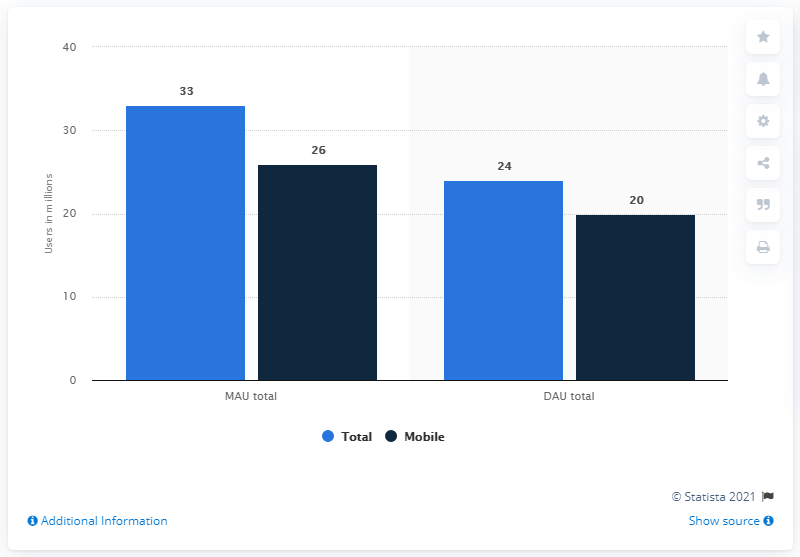List a handful of essential elements in this visual. As of June 2013, the number of daily active users of Facebook in the UK was 24 million. 